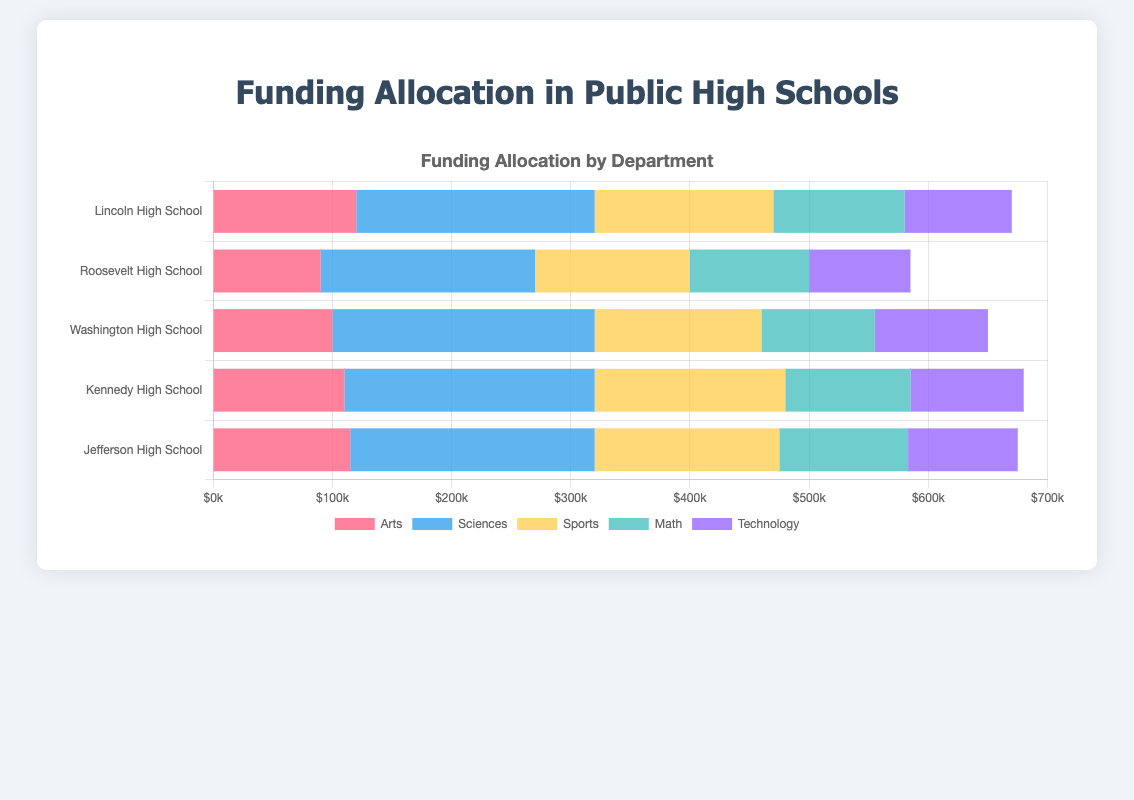What is the total funding allocated to the Sciences department across all high schools? To find the total funding for the Sciences department, sum up the allocation for Sciences from each high school: 200000 (Lincoln) + 180000 (Roosevelt) + 220000 (Washington) + 210000 (Kennedy) + 205000 (Jefferson) = 1015000
Answer: 1015000 Which high school allocates the most funding to the Arts department? Compare the funding allocated to the Arts department across all high schools: 120000 (Lincoln) vs 90000 (Roosevelt) vs 100000 (Washington) vs 110000 (Kennedy) vs 115000 (Jefferson). Lincoln High School has the highest allocation of 120000
Answer: Lincoln High School What is the average funding allocation for the Technology department across all high schools? Sum up the funding for Technology and divide by the number of high schools: (90000 + 85000 + 95000 + 95000 + 92000) / 5 = 457000 / 5 = 91400
Answer: 91400 Which high school has the smallest total funding allocation across all departments? Calculate and compare the total funding for each high school: Lincoln (670000), Roosevelt (585000), Washington (650000), Kennedy (680000), Jefferson (675000). Roosevelt has the smallest total with 585000
Answer: Roosevelt High School Which department consistently receives more than 100,000 in funding from all high schools? Check the funding for each department in all high schools: Arts has less than 100000 in Roosevelt (90000), Technology has less than 100000 in multiple schools, but Sciences exceeds 100000 for all schools: Lincoln (200000), Roosevelt (180000), Washington (220000), Kennedy (210000), Jefferson (205000)
Answer: Sciences In which school does the Sports department receive less funding than the Math department? Compare the funding for Sports and Math in each school: Lincoln (150000 Sports, 110000 Math), Roosevelt (130000 Sports, 100000 Math), Washington (140000 Sports, 95000 Math), Kennedy (160000 Sports, 105000 Math), Jefferson (155000 Sports, 108000 Math). Washington High School is the only one where Sports (140000) receives less than Math (95000)
Answer: Washington High School 